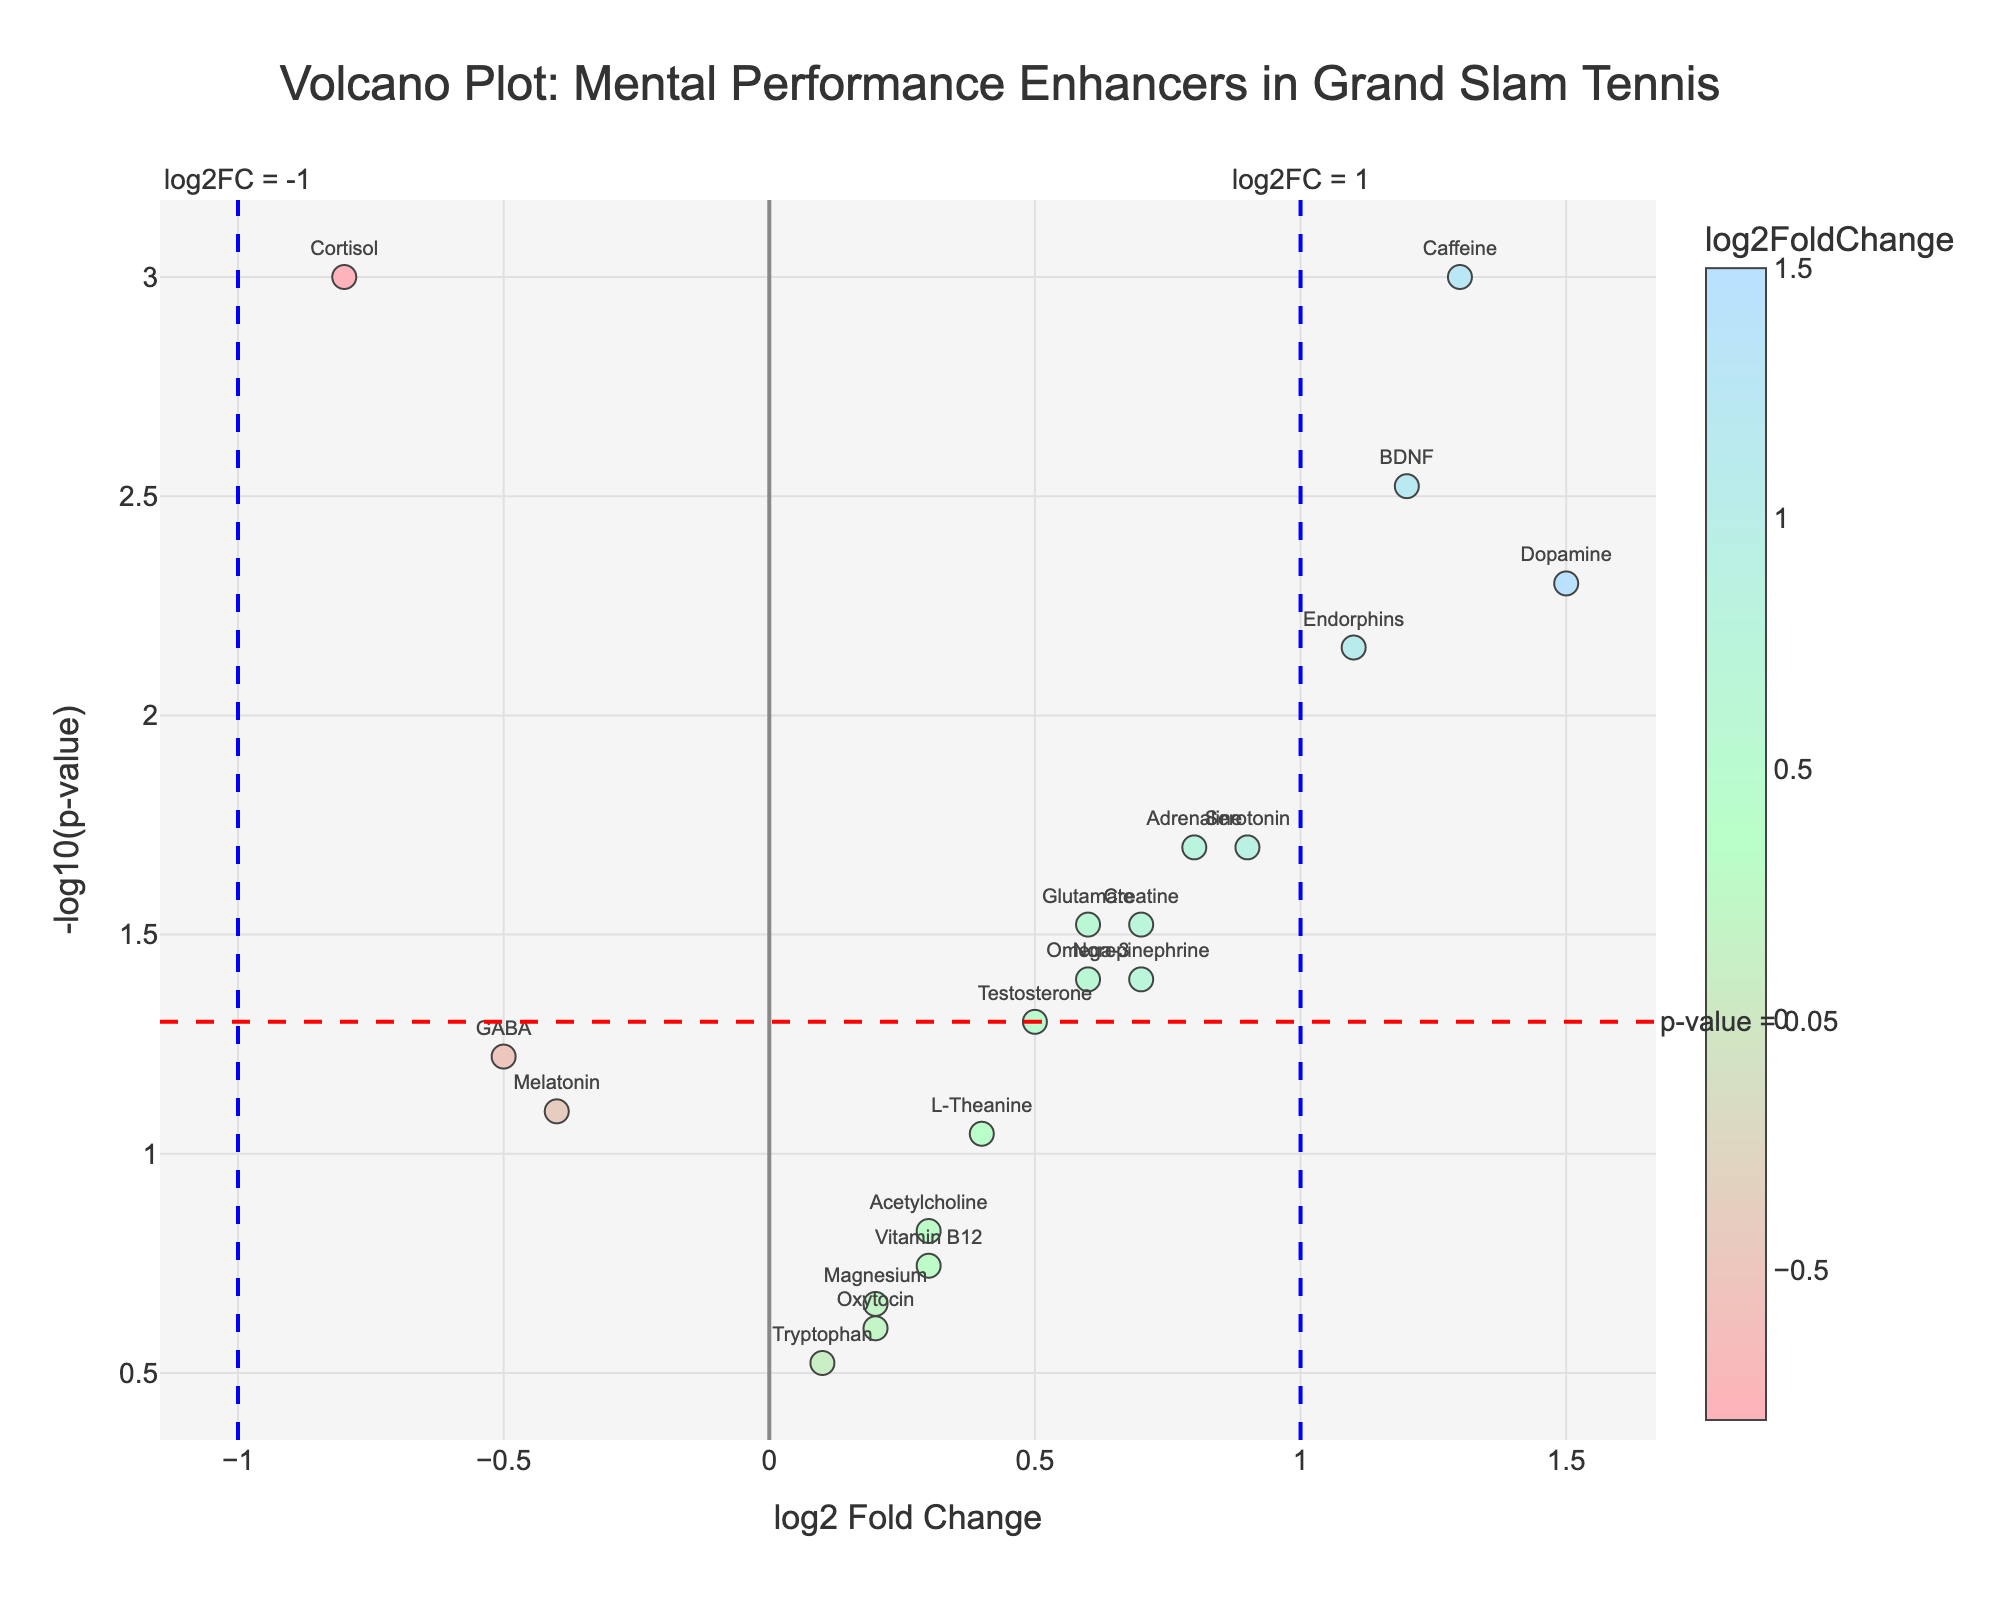What is the title of the plot? The title is typically found at the top of the plot and it gives an overview of what the plot is representing. In this case, it indicates the relationship of mental performance enhancers on Grand Slam performance.
Answer: Volcano Plot: Mental Performance Enhancers in Grand Slam Tennis How many enhancers have a log2FoldChange greater than 1? Look at the x-axis (log2 Fold Change) and count the number of points (data enhancers) situated to the right of the line x=1.
Answer: 3 Which enhancer has the highest log2FoldChange? Identify the data point that is farthest to the right on the x-axis which represents the highest log2FoldChange.
Answer: Dopamine What does the red dashed horizontal line represent? Dashed lines are often used to represent thresholds or significant values. The annotation on this line indicates it's the threshold for p-value significance (0.05).
Answer: p-value = 0.05 How many enhancers have a p-value below 0.05? Locate the red dashed horizontal line and count the number of points above this line as they represent p-values less than 0.05.
Answer: 10 Which enhancer has the smallest p-value, and what is its corresponding log2FoldChange? The smallest p-value corresponds to the highest -log10(p-value) on the y-axis. Identify the data point that is highest on the y-axis and note its x-axis value.
Answer: Cortisol, -0.8 Which enhancers fall into the significantly upregulated category (log2FoldChange > 1 and p-value < 0.05)? Focus on the top-right quadrant of the plot that is above the red horizontal line (p-value < 0.05) and right of the blue vertical line at log2FoldChange = 1. Identify the enhancers in this area.
Answer: Dopamine, Caffeine Are there any enhancers with a log2FoldChange close to 0 and a high p-value? Look near the center of the plot around the 0 mark on the x-axis and identify any enhancers that are low on the y-axis (since a high p-value corresponds to a low -log10(p-value)).
Answer: Tryptophan, Oxytocin, Magnesium Which enhancers are both upregulated (log2FoldChange > 0) and not statistically significant (p-value > 0.05)? Find the enhancers that are to the right of the y-axis (positive log2FoldChange) but below the red horizontal line (p-value > 0.05).
Answer: Acetylcholine, Oxytocin, Vitamin B12, Magnesium, Tryptophan 